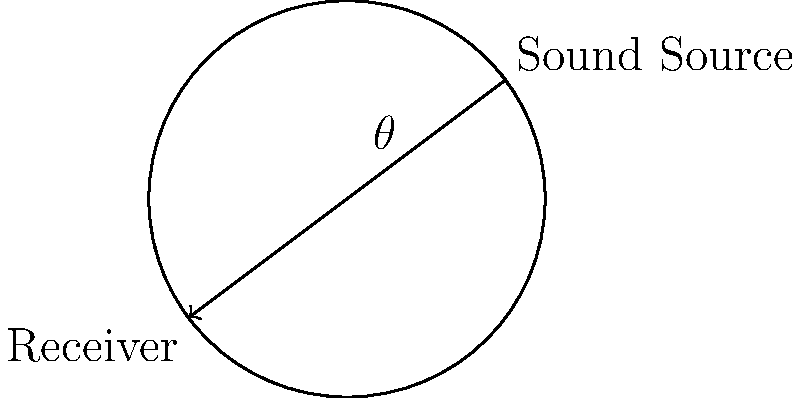In the circular reading room of the Library of Congress, a sound source and a receiver are positioned as shown in the diagram. If the room has a radius of 20 meters and the angle $\theta$ between the source and receiver is $120^\circ$, what is the difference in path length between the direct sound wave and the reflected sound wave that bounces off the wall? Let's approach this step-by-step:

1) First, we need to calculate the direct path length. This is simply the chord length between the source and receiver.
   The chord length $c$ for a circle with radius $r$ and central angle $\theta$ (in radians) is given by:
   $$c = 2r \sin(\frac{\theta}{2})$$

2) Convert the angle from degrees to radians:
   $$\theta = 120^\circ = \frac{2\pi}{3} \text{ radians}$$

3) Now we can calculate the direct path length:
   $$c = 2 \cdot 20 \cdot \sin(\frac{\pi}{3}) = 40 \cdot \frac{\sqrt{3}}{2} = 20\sqrt{3} \text{ meters}$$

4) The reflected path consists of two parts: from the source to the wall, and from the wall to the receiver.
   This is equal to the arc length of the circle between the source and receiver.

5) The arc length $s$ for a circle with radius $r$ and central angle $\theta$ (in radians) is given by:
   $$s = r\theta$$

6) Calculate the reflected path length:
   $$s = 20 \cdot \frac{2\pi}{3} = \frac{40\pi}{3} \text{ meters}$$

7) The difference in path length is the reflected path minus the direct path:
   $$\text{Difference} = \frac{40\pi}{3} - 20\sqrt{3} \text{ meters}$$
Answer: $\frac{40\pi}{3} - 20\sqrt{3}$ meters 